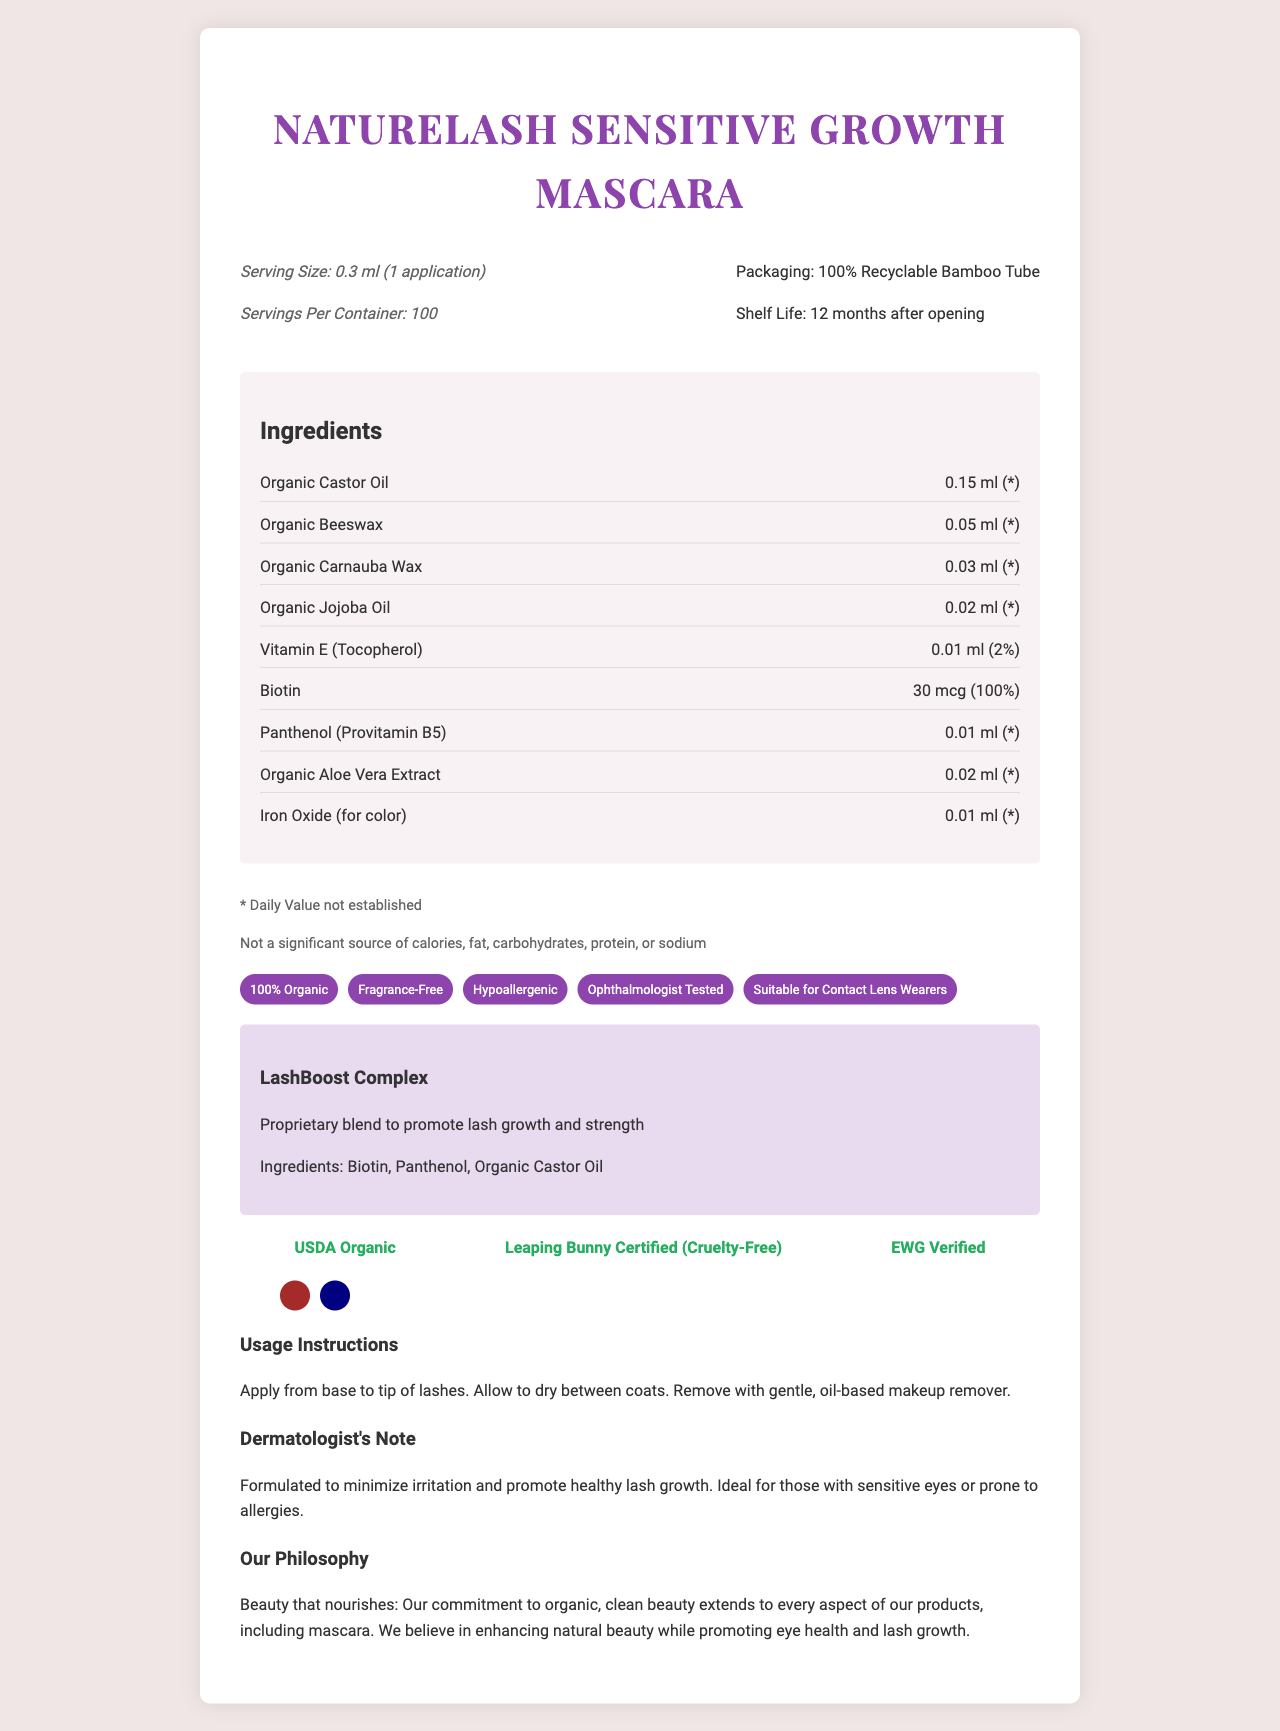what is the serving size mentioned on the document? The serving size is listed at the top of the document under the product name and packaging information.
Answer: 0.3 ml (1 application) what is the shelf life mentioned for this mascara? The shelf life is noted as "12 months after opening" in the product information section.
Answer: 12 months after opening describe the ingredients used in the LashBoost Complex. This information is found in the section dedicated to the LashBoost Complex, where it lists the ingredients and their purpose.
Answer: The LashBoost Complex includes Biotin, Panthenol, and Organic Castor Oil. how much Biotin is present per application? The amount of Biotin per application is listed under the ingredients section.
Answer: 30 mcg which ingredient has the highest daily value percentage? Among all ingredients, Biotin has the highest daily value percentage of 100%.
Answer: Biotin (100%) is this product suitable for contact lens wearers? The document states that the mascara is "Suitable for Contact Lens Wearers” in the claims section.
Answer: Yes what is the packaging material of the product? The packaging information specifies that the mascara is contained in a 100% Recyclable Bamboo Tube.
Answer: 100% Recyclable Bamboo Tube what are the color options available for this mascara? The color options are listed towards the end of the document, as visual color circles and text.
Answer: Jet Black, Brown, Navy what certifications does this product hold? This certification information is displayed on the document as icons with descriptions underneath.
Answer: USDA Organic, Leaping Bunny Certified (Cruelty-Free), EWG Verified which of the following is NOT an ingredient in the mascara? A. Organic Castor Oil B. Organic Aloe Vera Extract C. Synthetic Fragrance D. Vitamin E Synthetic Fragrance is listed under the "free from" section, meaning it is not an ingredient in the mascara.
Answer: C which of these claims are NOT made by NatureLash Sensitive Growth Mascara? A. 100% Organic B. Gluten-Free C. Preservative-Free D. Hypoallergenic The mascara is described as 100% Organic, Gluten-Free, and Hypoallergenic, but "Preservative-Free" is not mentioned in the claims.
Answer: C is the daily value percentage established for all ingredients? The document specifies "* Daily Value not established" for several ingredients.
Answer: No summarize the main features of NatureLash Sensitive Growth Mascara. The document covers various aspects of the product, including its ingredients, certifications, claims, and usage instructions.
Answer: NatureLash Sensitive Growth Mascara is an organic, fragrance-free mascara formulated for sensitive eyes and lash growth, featuring ingredients like Organic Castor Oil and Biotin. It is offered in recyclable bamboo packaging, available in multiple colors, and claims to be hypoallergenic, ophthalmologist tested, and suitable for contact lens wearers. It holds certifications such as USDA Organic, Leaping Bunny Certified, and EWG Verified. what percentage of the daily value for Vitamin E is provided per application? Under the ingredients section, it states that Vitamin E provides 2% of the daily value per application.
Answer: 2% can you determine the exact number of calories in one application of this mascara? The document mentions "Not a significant source of calories," but does not provide an exact number of calories.
Answer: Not enough information is this product free from GMOs? The document lists several "free from" claims, including GMOs, indicating that the product does not contain genetically modified organisms.
Answer: Yes 